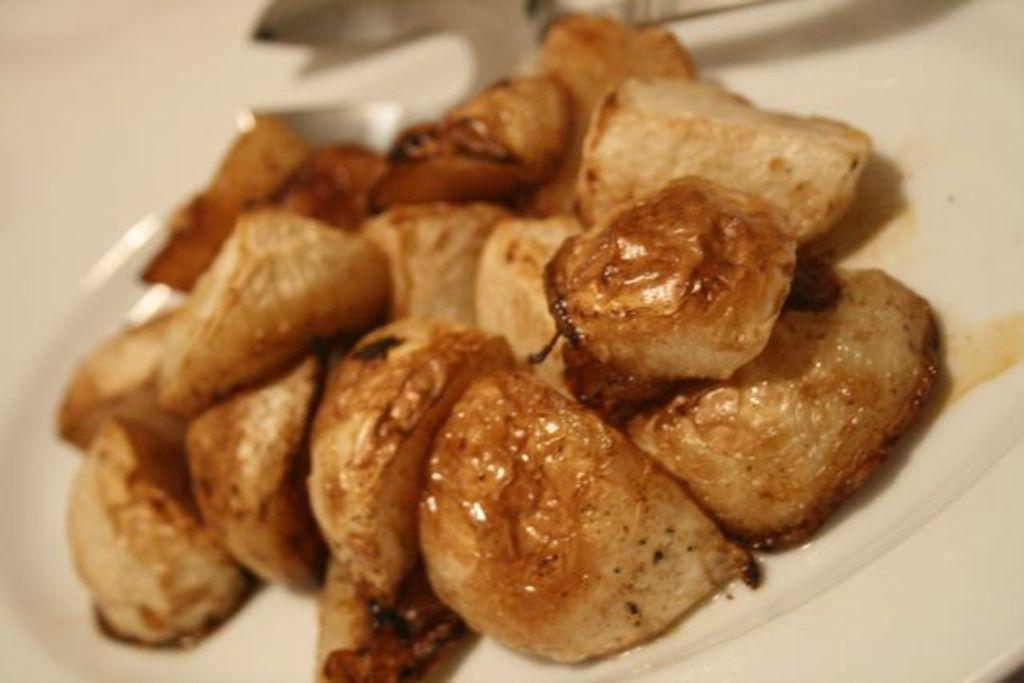What is present on the plate in the image? The plate contains food items. Can you describe the background of the image? The background of the image is blurred. What type of gold form can be seen in the image? There is no gold form present in the image. 